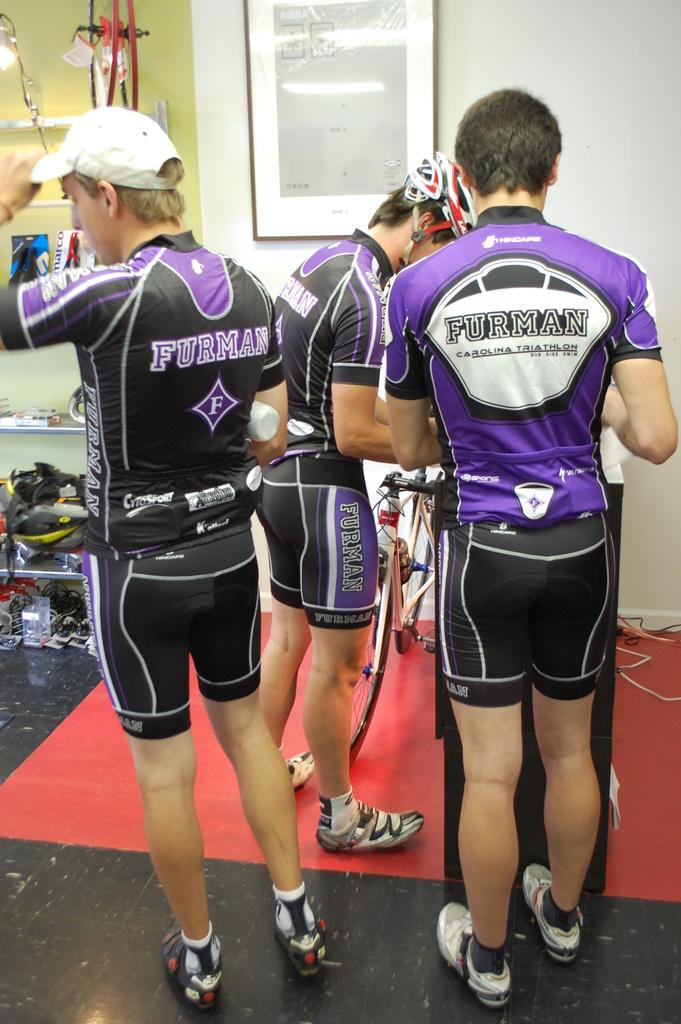<image>
Relay a brief, clear account of the picture shown. a group of guys that have Furman on their backs 